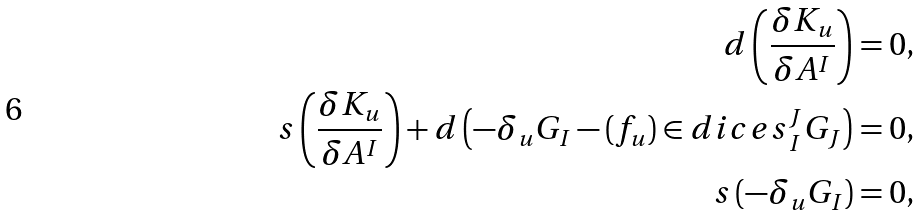Convert formula to latex. <formula><loc_0><loc_0><loc_500><loc_500>d \left ( \frac { \delta K _ { u } } { \delta A ^ { I } } \right ) & = 0 , \\ s \left ( \frac { \delta K _ { u } } { \delta A ^ { I } } \right ) + d \left ( - \delta _ { u } G _ { I } - ( f _ { u } ) \in d i c e s { ^ { J } _ { I } } G _ { J } \right ) & = 0 , \\ s \left ( - \delta _ { u } G _ { I } \right ) & = 0 ,</formula> 